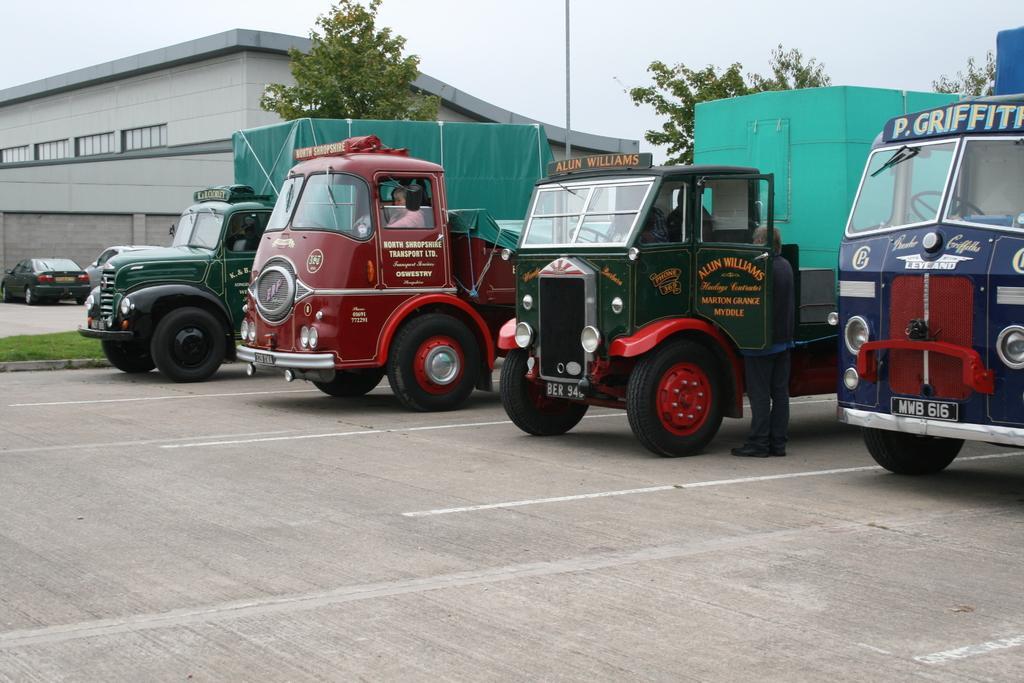Please provide a concise description of this image. This picture is clicked outside. On the right we can see the vehicles seems to be parked on the ground and we can see a person standing on the ground and we can see a person sitting in the vehicle and we can see the text on the vehicles. In the background we can see the sky, building, trees, pole, green grass and some objects. 